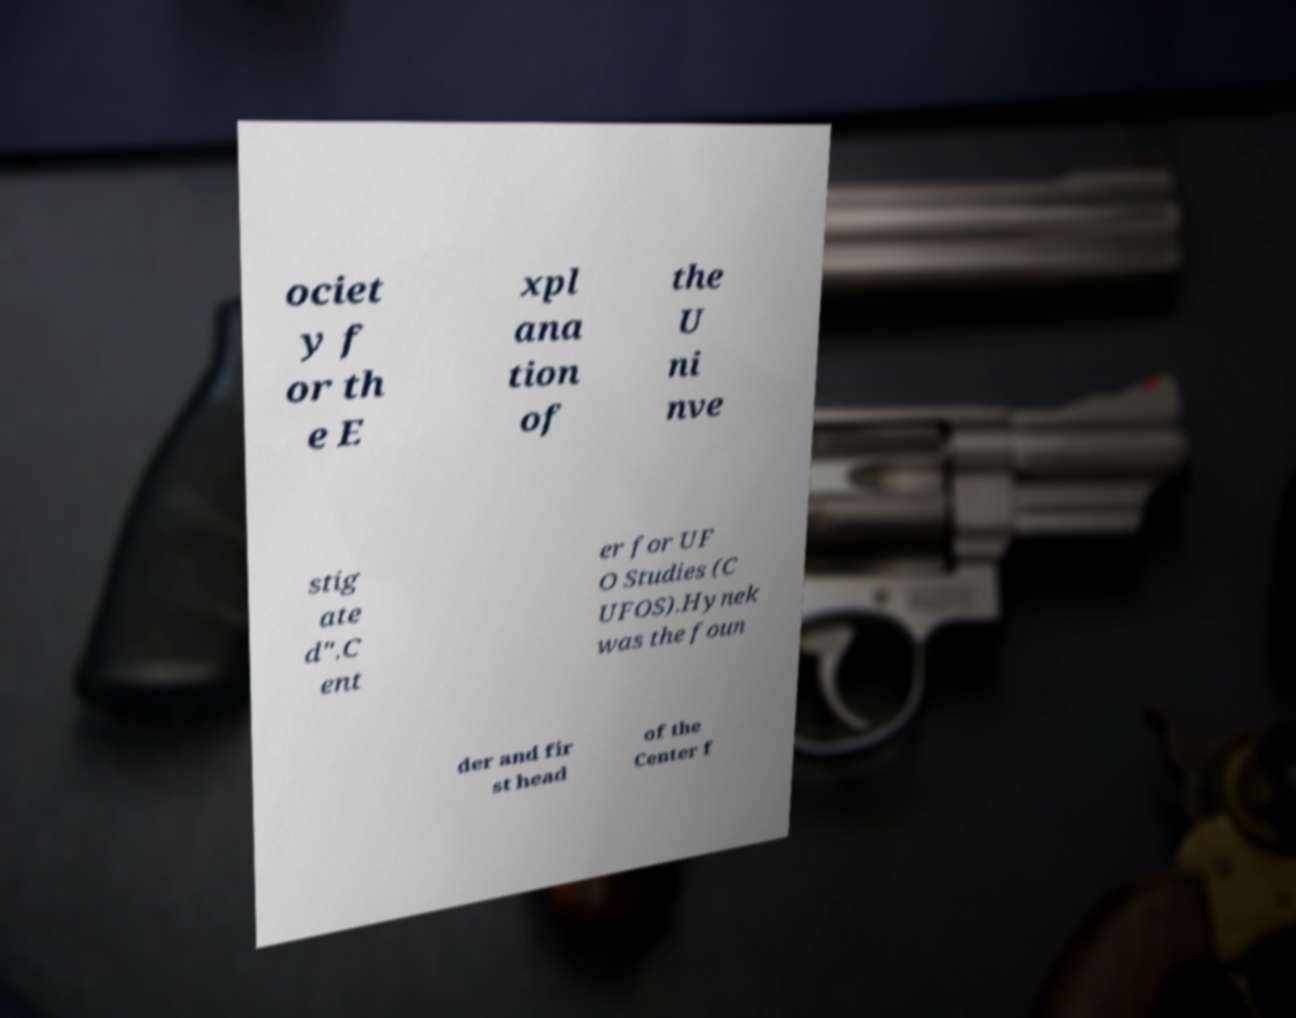There's text embedded in this image that I need extracted. Can you transcribe it verbatim? ociet y f or th e E xpl ana tion of the U ni nve stig ate d".C ent er for UF O Studies (C UFOS).Hynek was the foun der and fir st head of the Center f 